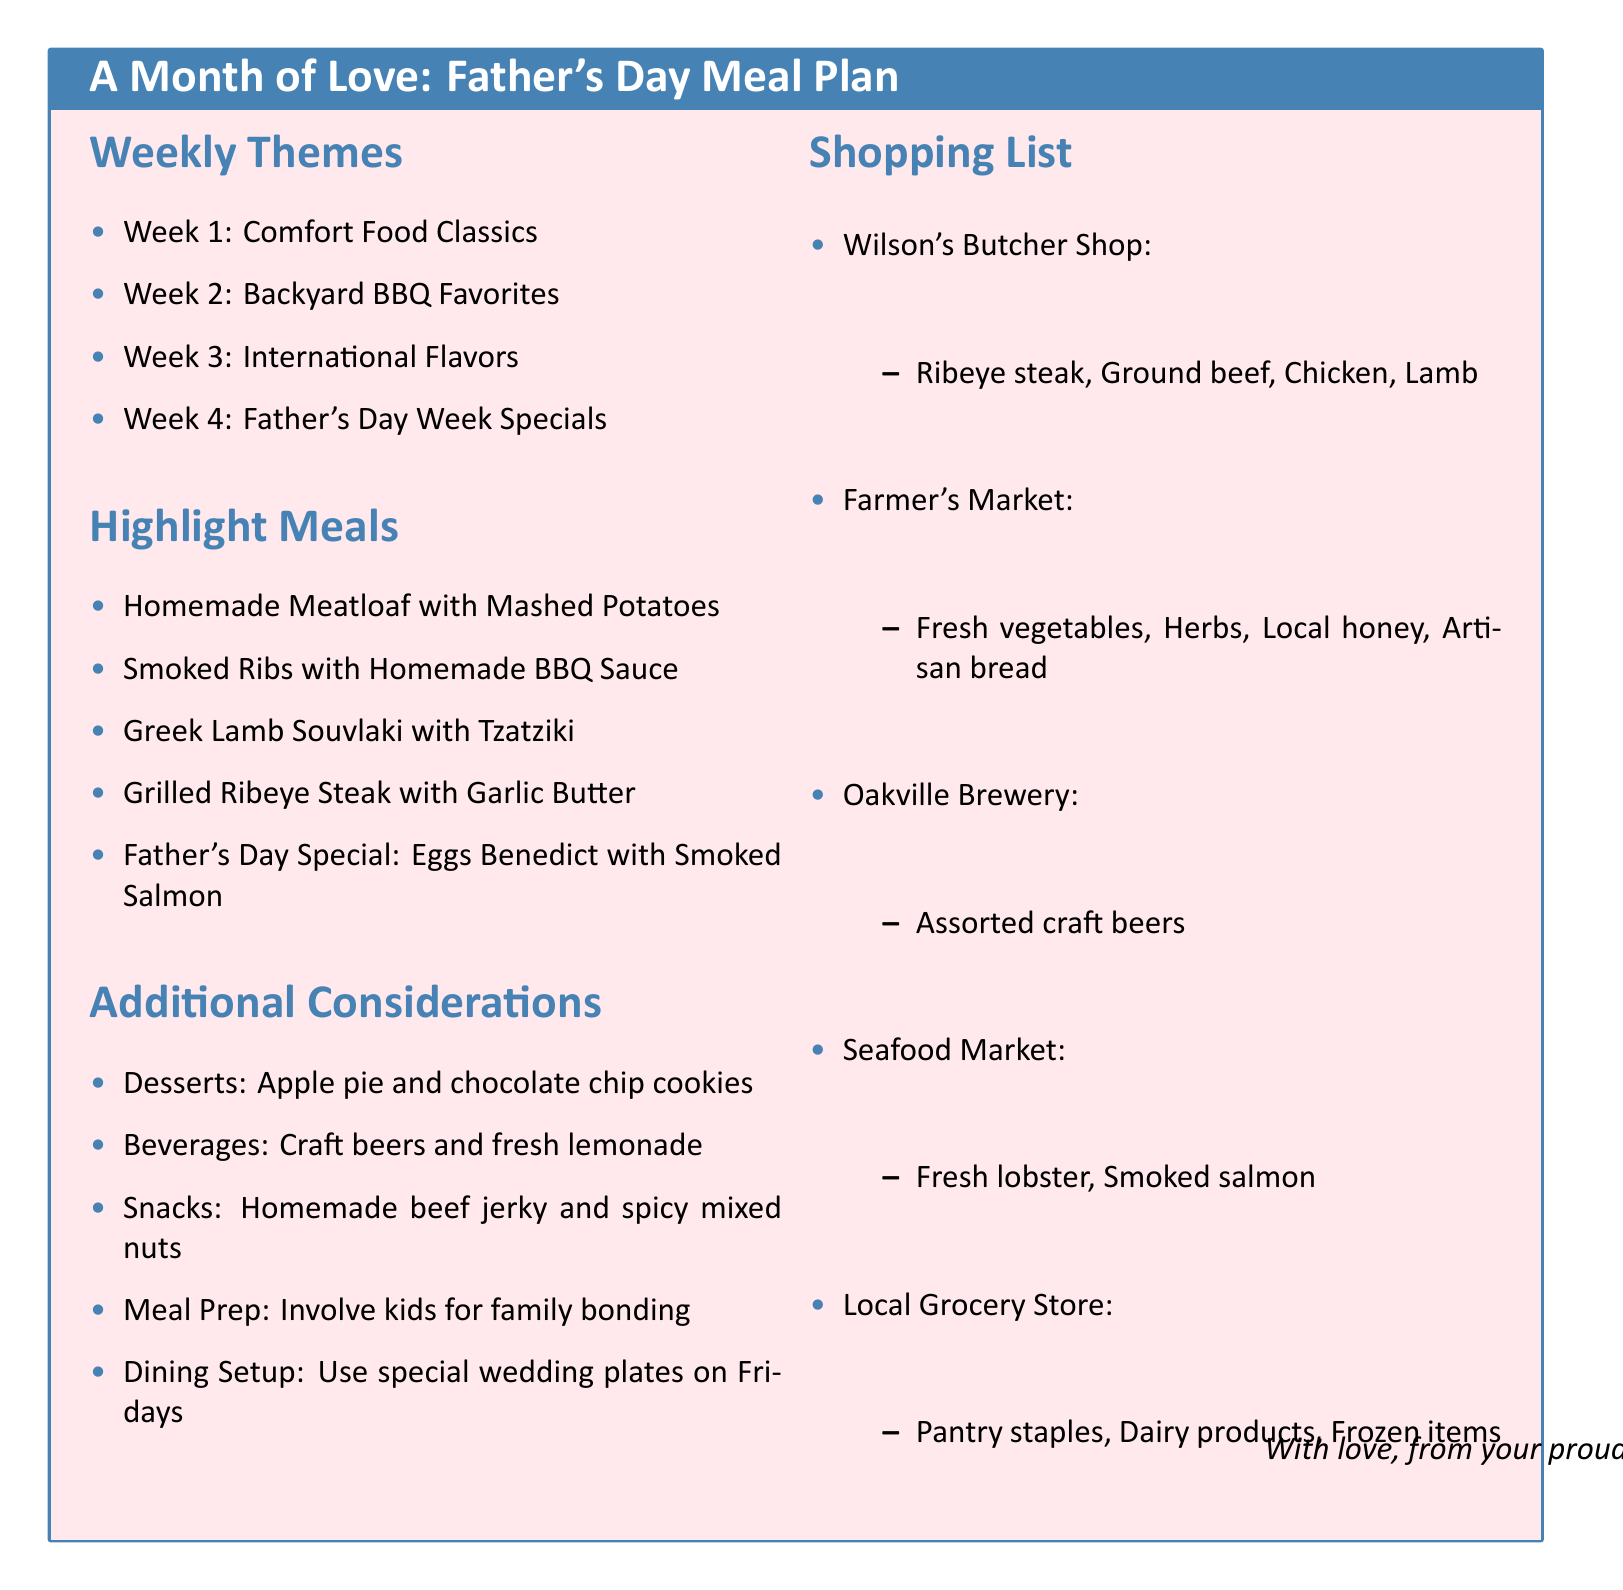What is the theme for Week 1? The theme for Week 1 is listed in the document under "Weekly Themes," and it is "Comfort Food Classics."
Answer: Comfort Food Classics What dish is featured on Father's Day? The special dish for Father's Day can be found in the "Father's Day Week Specials" section of the document. It is "Eggs Benedict with Smoked Salmon."
Answer: Eggs Benedict with Smoked Salmon Which store sells ribeye steak? The store that sells ribeye steak is mentioned in the "Shopping List" section, specifically under "Wilson's Butcher Shop."
Answer: Wilson's Butcher Shop What dessert is suggested to include throughout the month? The document mentions specific desserts that should be included, with the first being "apple pie."
Answer: Apple pie How many weeks are covered in the meal plan? The document lists themes for each week, indicating that there are a total of four weeks covered.
Answer: Four weeks What meal is scheduled for Saturday of Week 2? The document specifies the meal for Saturday under "Week 2," which is "Beer Can Chicken with Coleslaw."
Answer: Beer Can Chicken with Coleslaw What beverage is suggested to stock up on? The document outlines beverages to stock up on, indicating that "craft beers" are included.
Answer: Craft beers What is the focus of the additional considerations section? The "Additional Considerations" section includes various items related to meal preparation, dining setup, and family involvement, highlighting family activities.
Answer: Family bonding 